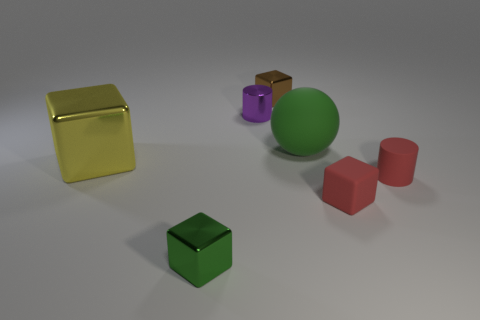Subtract all brown blocks. How many blocks are left? 3 Add 2 green blocks. How many objects exist? 9 Subtract all red cubes. How many cubes are left? 3 Subtract 1 cubes. How many cubes are left? 3 Subtract all cylinders. How many objects are left? 5 Subtract all yellow blocks. Subtract all blue cylinders. How many blocks are left? 3 Add 5 big rubber objects. How many big rubber objects are left? 6 Add 1 cylinders. How many cylinders exist? 3 Subtract 0 cyan balls. How many objects are left? 7 Subtract all big metal blocks. Subtract all metallic cylinders. How many objects are left? 5 